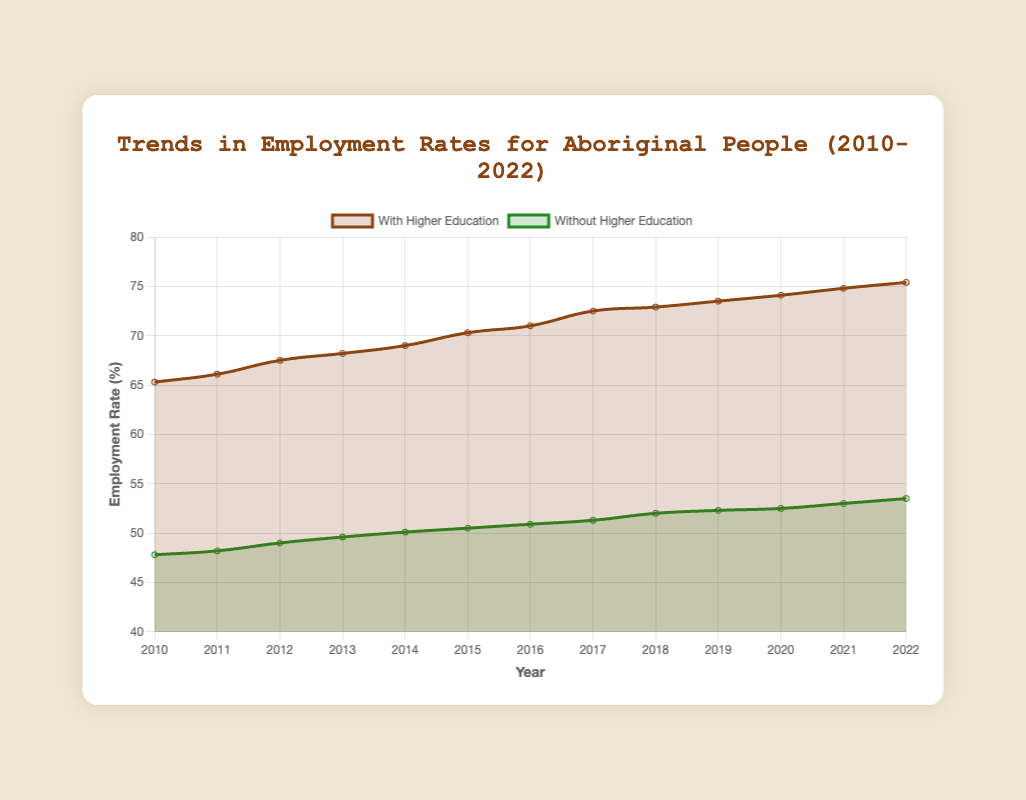What is the employment rate for Aboriginal people with higher education in 2015? The employment rate for Aboriginal people with higher education in 2015 can be directly read from the 'With Higher Education' dataset for the year 2015 in the figure.
Answer: 70.3% How much did the employment rate for Aboriginal people without higher education increase from 2010 to 2022? The employment rate for Aboriginal people without higher education in 2010 is 47.8%, and in 2022 is 53.5%. The increase can be found by calculating the difference: 53.5% - 47.8% = 5.7%.
Answer: 5.7% Which group saw a higher overall increase in employment rate from 2010 to 2022? To determine the group with a higher overall increase, calculate the difference for both groups from 2010 to 2022. For 'With Higher Education': 75.4% - 65.3% = 10.1%. For 'Without Higher Education': 53.5% - 47.8% = 5.7%. The group with a higher increase is 'With Higher Education'.
Answer: With Higher Education What is the average employment rate for Aboriginal people without higher education over the years shown? The sum of the employment rates for 'Without Higher Education' from 2010 to 2022 is: (47.8 + 48.2 + 49.0 + 49.6 + 50.1 + 50.5 + 50.9 + 51.3 + 52.0 + 52.3 + 52.5 + 53.0 + 53.5) = 661.7. Dividing by the number of years (13), the average is 661.7 / 13 = 50.9%.
Answer: 50.9% By how much did the employment rate for Aboriginal people with higher education exceed the employment rate for those without higher education in 2021? In 2021, the employment rate for 'With Higher Education' was 74.8%, and for 'Without Higher Education' it was 53.0%. The difference is 74.8% - 53.0% = 21.8%.
Answer: 21.8% In what year did the employment rate for Aboriginal people with higher education first exceed 70%? The employment rate for 'With Higher Education' first exceeds 70% in the year 2015.
Answer: 2015 What trend is observed in the employment rate of Aboriginal people with higher education from 2010 to 2022? Observing the curve for 'With Higher Education' from 2010 to 2022, there is a consistent upward trend in the employment rate.
Answer: Upward trend 